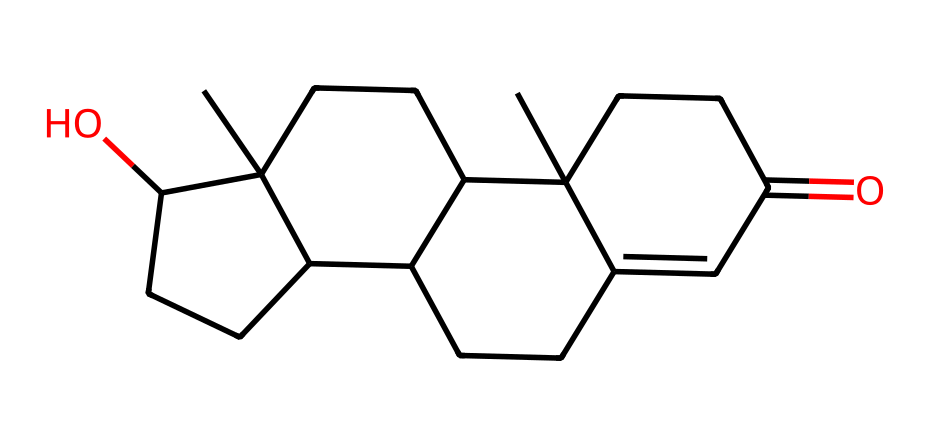what is the molecular formula of testosterone? To determine the molecular formula, we identify the types and counts of atoms in the provided SMILES representation. From the structure, we can count 19 carbons (C), 28 hydrogens (H), and 2 oxygens (O), leading to the formula: C19H28O2.
Answer: C19H28O2 how many rings are present in the structure of testosterone? By analyzing the cyclic portions of the SMILES string, we observe that the numbering indicates four ring structures, which are distinctively indicated by the numbers (1, 2, 3, 4). Thus, there are four rings present.
Answer: 4 what is the significance of the hydroxyl group in testosterone? The hydroxyl group (-OH) present in testosterone serves as a functional group that affects its biological activity, particularly in binding to receptors and influencing metabolic processes. This is crucial for its function as a hormone.
Answer: biological activity how many geometric isomers can testosterone have? Testosterone can exhibit geometric isomerism due to the presence of a double bond in the structure, which can have different spatial arrangements (cis/trans). Overall, testosterone can have two geometric isomers based on the configuration around this double bond.
Answer: 2 identify one type of geometric isomer for testosterone. One type of geometric isomer for testosterone involves the arrangement around its carbon-carbon double bond. Specifically, if we consider the double bond configuration, it can be classified as "cis" or "trans", with one example being cis-testosterone.
Answer: cis-testosterone what element creates the double bond in testosterone? The double bond in testosterone is formed between two carbon atoms (C), thus the relevant element contributing to the double bond is carbon.
Answer: carbon 